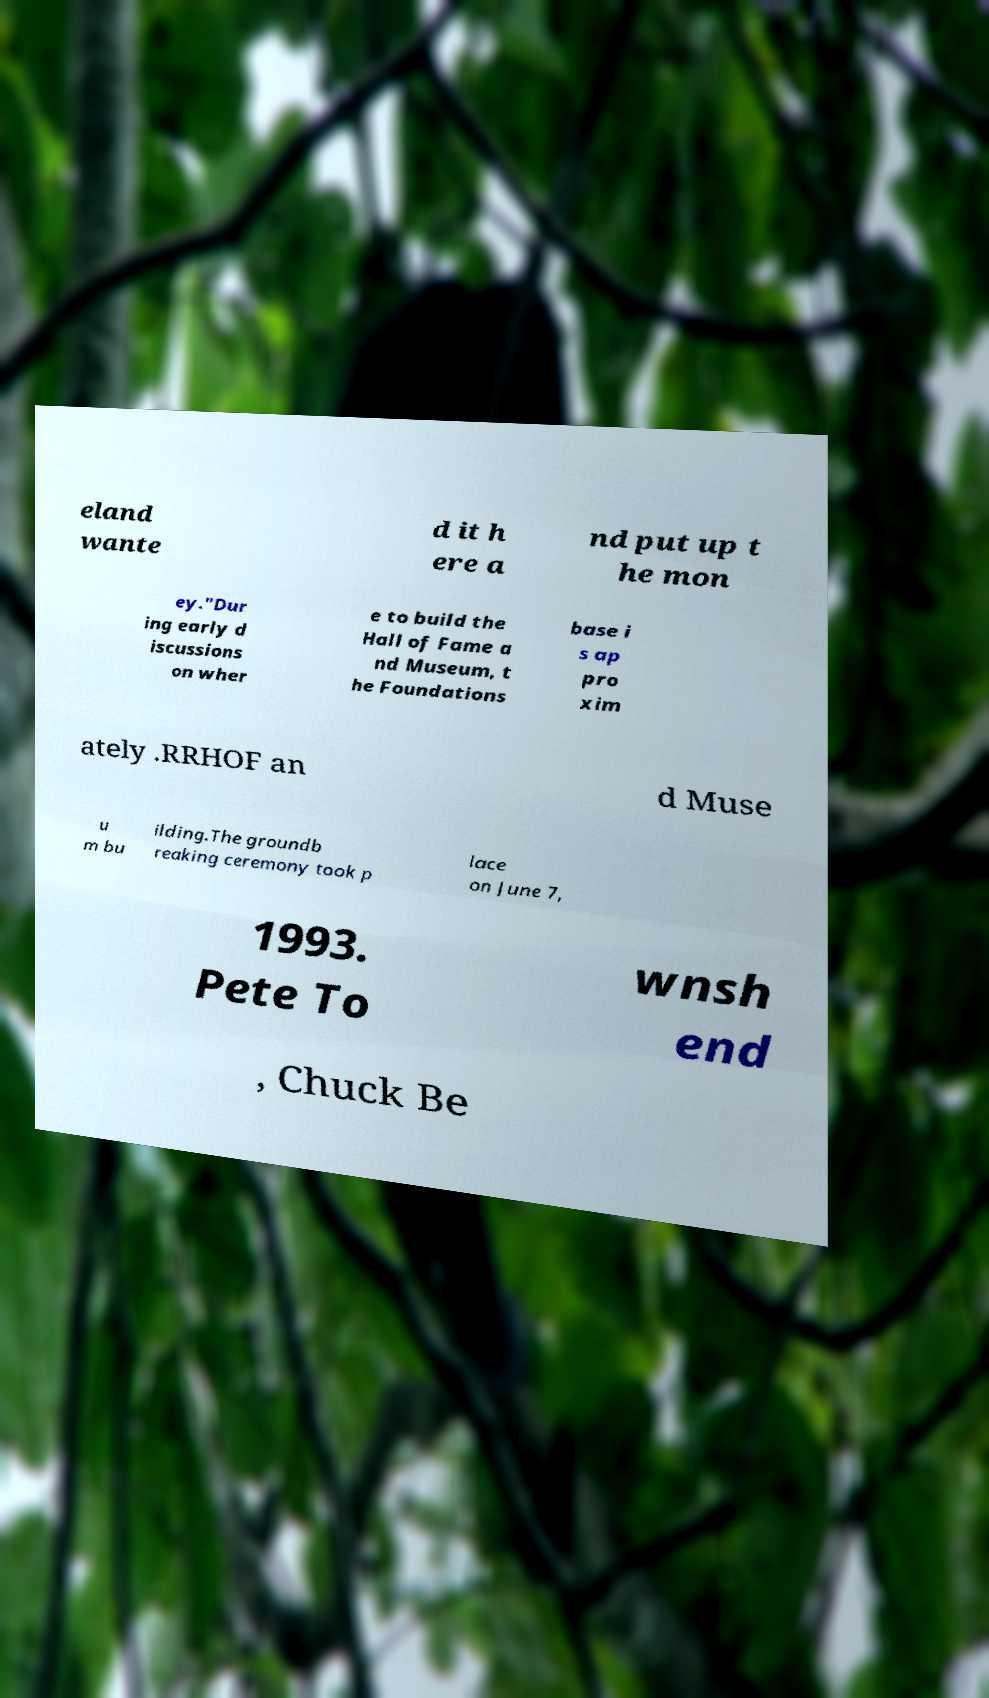I need the written content from this picture converted into text. Can you do that? eland wante d it h ere a nd put up t he mon ey."Dur ing early d iscussions on wher e to build the Hall of Fame a nd Museum, t he Foundations base i s ap pro xim ately .RRHOF an d Muse u m bu ilding.The groundb reaking ceremony took p lace on June 7, 1993. Pete To wnsh end , Chuck Be 